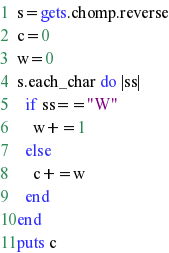<code> <loc_0><loc_0><loc_500><loc_500><_Ruby_>s=gets.chomp.reverse
c=0
w=0
s.each_char do |ss|
  if ss=="W"
    w+=1
  else
    c+=w
  end
end
puts c
</code> 